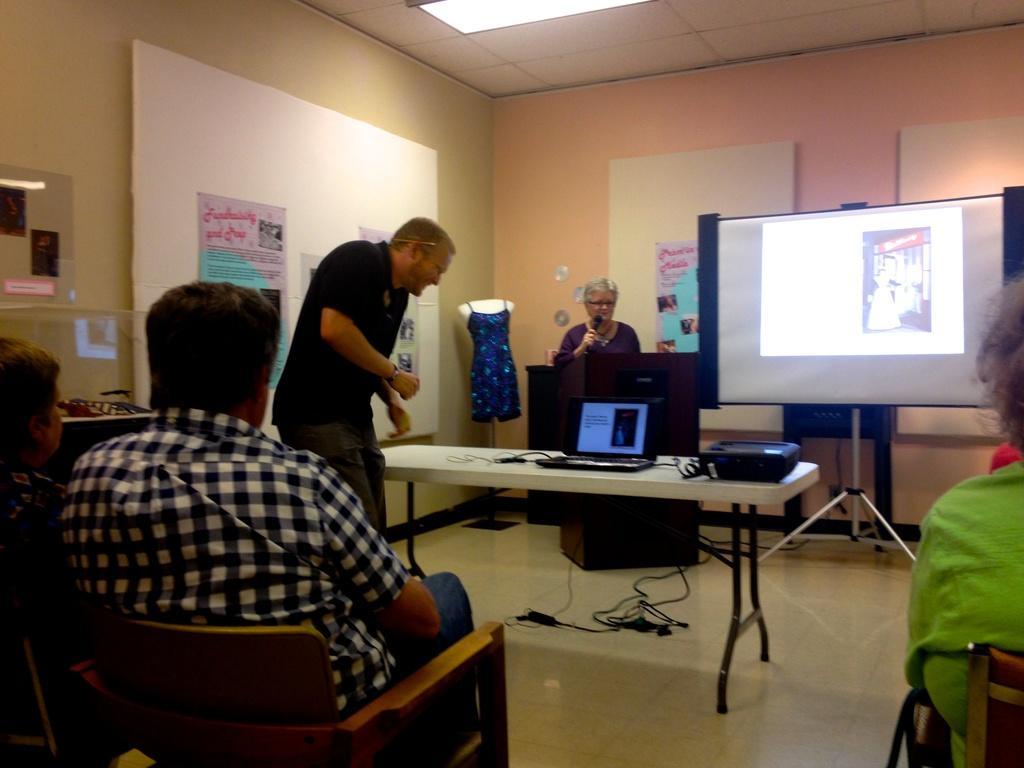Could you give a brief overview of what you see in this image? In this picture we can see three people sitting on chairs and two people standing, in the middle we can see a table, on that table we can see a laptop, in the background there is a projector screen, behind the projector screen there is a woman standing in front of a speech desk holding a microphone, in the background we can see clothes and also there is some banners here. 